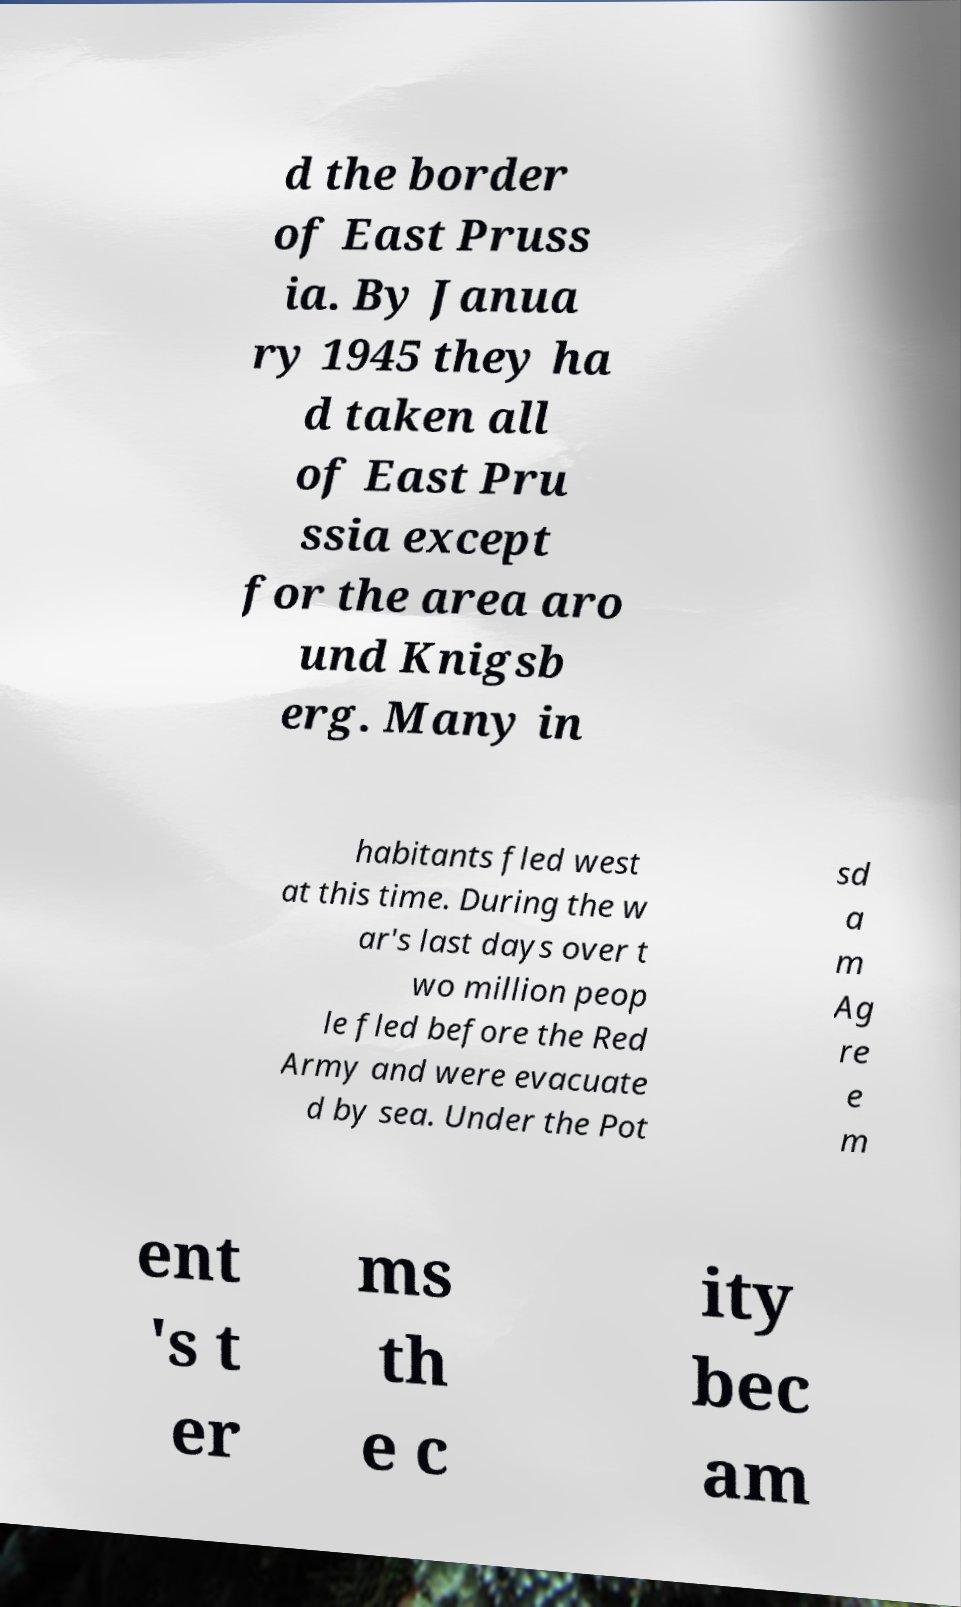Could you assist in decoding the text presented in this image and type it out clearly? d the border of East Pruss ia. By Janua ry 1945 they ha d taken all of East Pru ssia except for the area aro und Knigsb erg. Many in habitants fled west at this time. During the w ar's last days over t wo million peop le fled before the Red Army and were evacuate d by sea. Under the Pot sd a m Ag re e m ent 's t er ms th e c ity bec am 